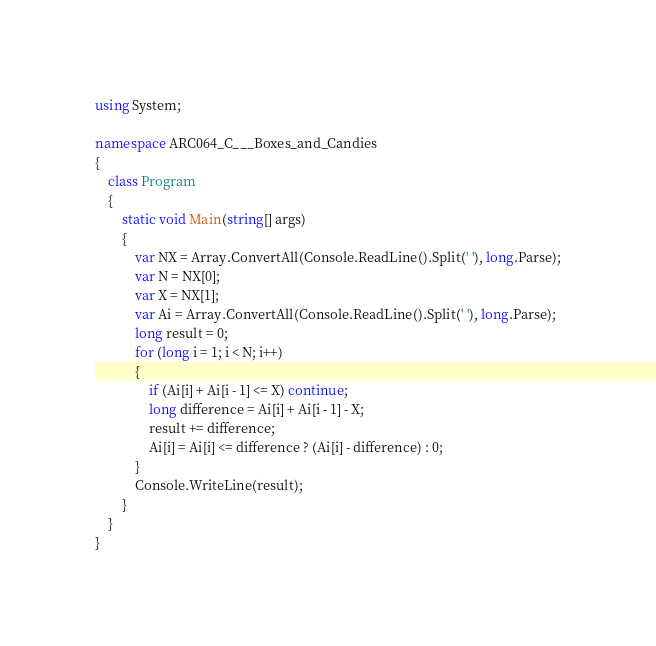<code> <loc_0><loc_0><loc_500><loc_500><_C#_>using System;

namespace ARC064_C___Boxes_and_Candies
{
    class Program
    {
        static void Main(string[] args)
        {
            var NX = Array.ConvertAll(Console.ReadLine().Split(' '), long.Parse);
            var N = NX[0];
            var X = NX[1];
            var Ai = Array.ConvertAll(Console.ReadLine().Split(' '), long.Parse);
            long result = 0;
            for (long i = 1; i < N; i++)
            {
                if (Ai[i] + Ai[i - 1] <= X) continue;
                long difference = Ai[i] + Ai[i - 1] - X;
                result += difference;
                Ai[i] = Ai[i] <= difference ? (Ai[i] - difference) : 0;
            }
            Console.WriteLine(result);
        }
    }
}
</code> 